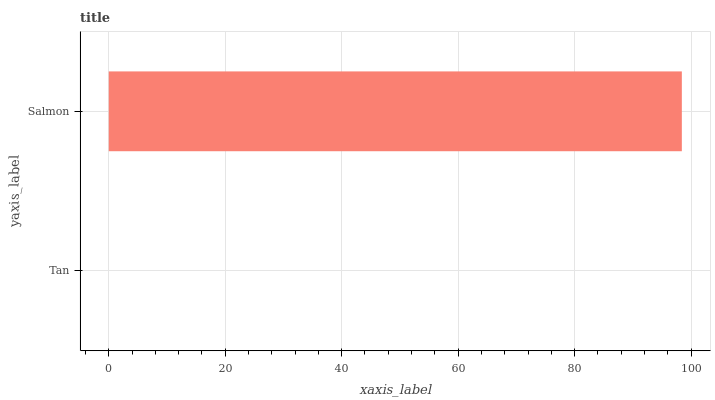Is Tan the minimum?
Answer yes or no. Yes. Is Salmon the maximum?
Answer yes or no. Yes. Is Salmon the minimum?
Answer yes or no. No. Is Salmon greater than Tan?
Answer yes or no. Yes. Is Tan less than Salmon?
Answer yes or no. Yes. Is Tan greater than Salmon?
Answer yes or no. No. Is Salmon less than Tan?
Answer yes or no. No. Is Salmon the high median?
Answer yes or no. Yes. Is Tan the low median?
Answer yes or no. Yes. Is Tan the high median?
Answer yes or no. No. Is Salmon the low median?
Answer yes or no. No. 